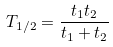<formula> <loc_0><loc_0><loc_500><loc_500>T _ { 1 / 2 } = \frac { t _ { 1 } t _ { 2 } } { t _ { 1 } + t _ { 2 } }</formula> 